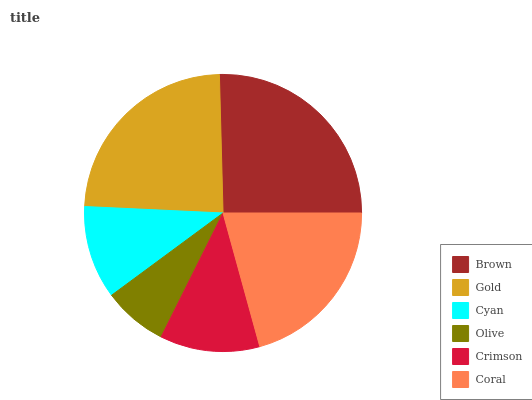Is Olive the minimum?
Answer yes or no. Yes. Is Brown the maximum?
Answer yes or no. Yes. Is Gold the minimum?
Answer yes or no. No. Is Gold the maximum?
Answer yes or no. No. Is Brown greater than Gold?
Answer yes or no. Yes. Is Gold less than Brown?
Answer yes or no. Yes. Is Gold greater than Brown?
Answer yes or no. No. Is Brown less than Gold?
Answer yes or no. No. Is Coral the high median?
Answer yes or no. Yes. Is Crimson the low median?
Answer yes or no. Yes. Is Crimson the high median?
Answer yes or no. No. Is Coral the low median?
Answer yes or no. No. 